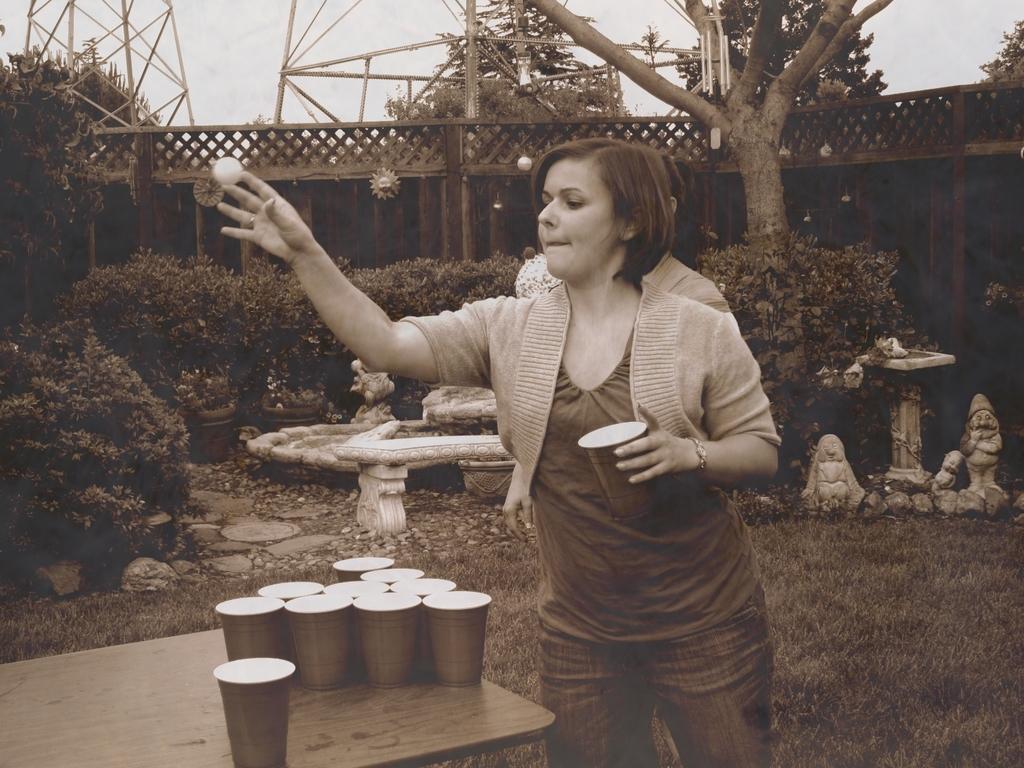Can you describe this image briefly? This is a picture outside of a house and there is a grass on the floor and there are some sculpture on the floor and a woman stand and playing a game. And there is a table and there are glasses kept on the table And there are plants and there is a sky visible 